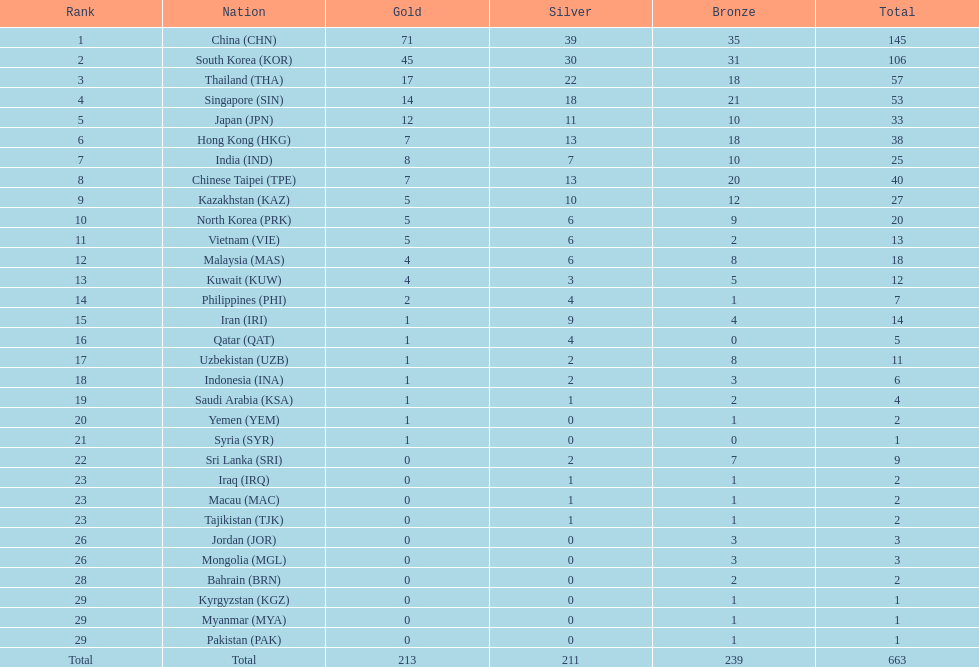How many more gold medals must qatar win before they can earn 12 gold medals? 11. 